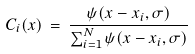<formula> <loc_0><loc_0><loc_500><loc_500>C _ { i } ( x ) \, = \, \frac { \psi ( x - x _ { i } , \sigma ) } { \sum _ { i = 1 } ^ { N } \psi ( x - x _ { i } , \sigma ) }</formula> 